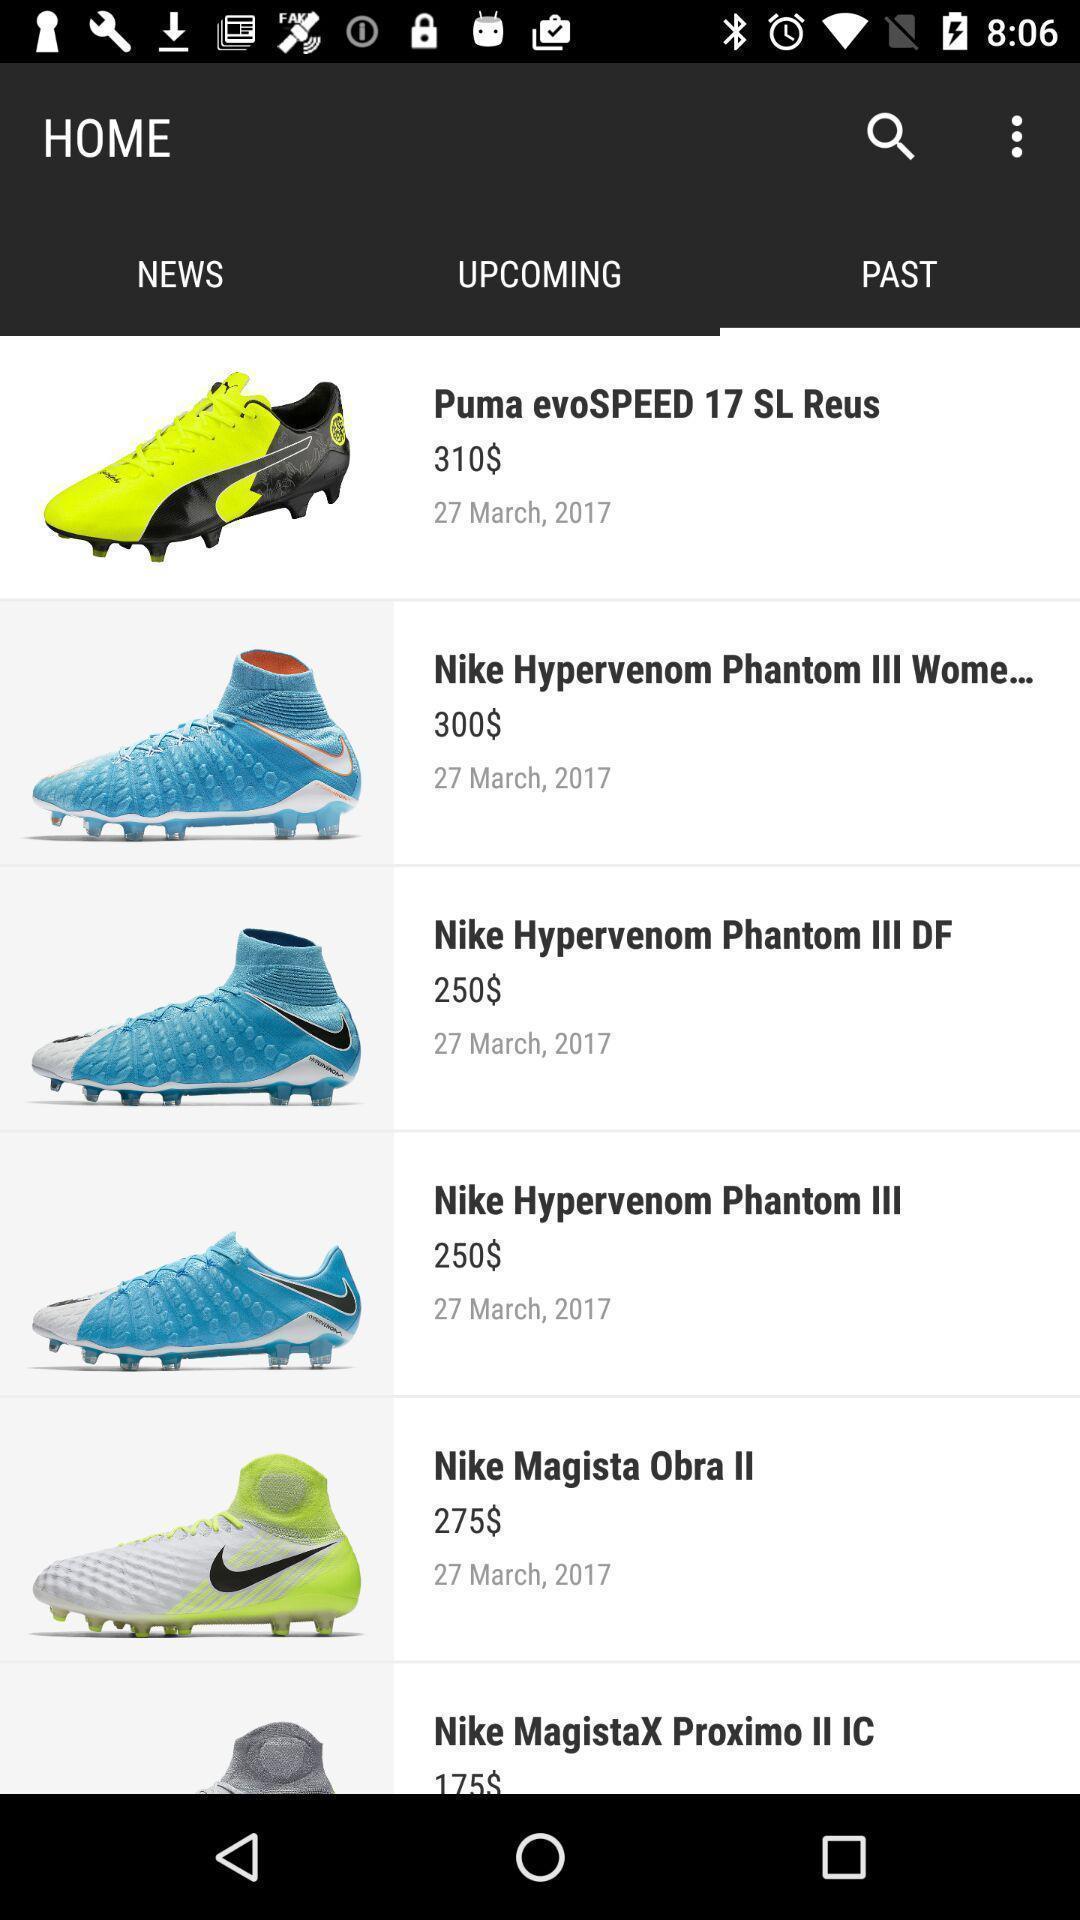Describe the key features of this screenshot. Screen displaying the list of soccer cleats. 